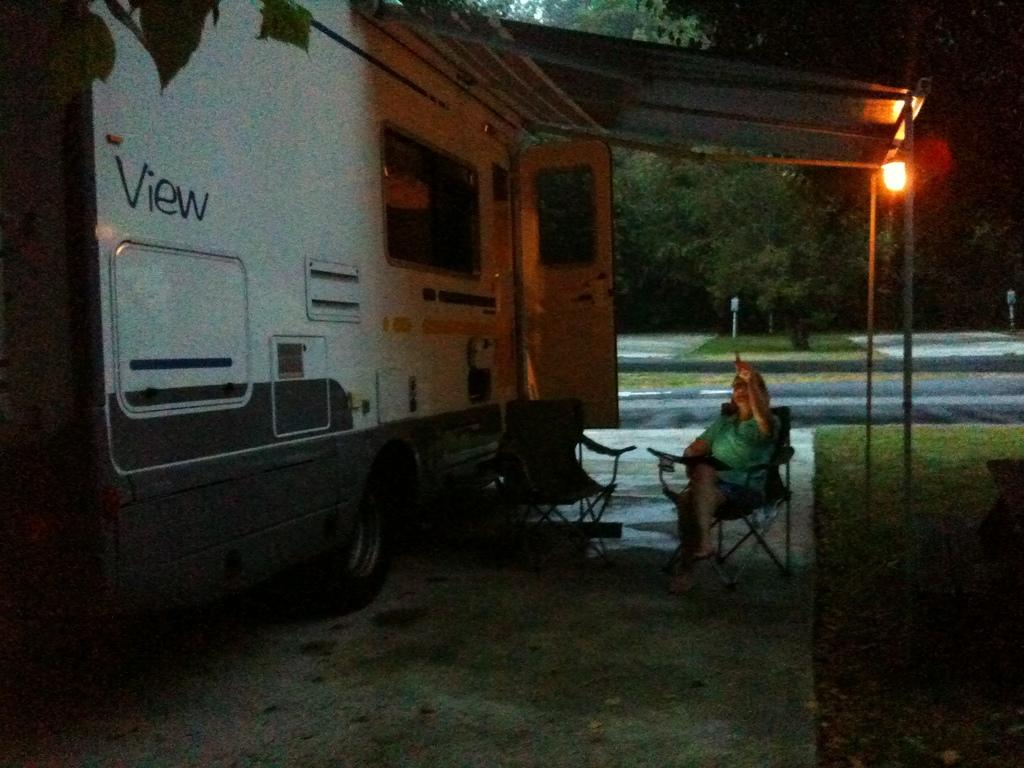What is the main subject of the image? The main subject of the image is a truck. What is happening in front of the truck? There is a lady sitting on chairs in front of the truck. What type of natural environment is visible in the image? There are trees and grass in the image. Can you describe any man-made objects in the image? There is a lamp in the image. What type of feast is being prepared in the image? There is no indication of a feast being prepared in the image. Can you see any bears in the image? There are no bears present in the image. 